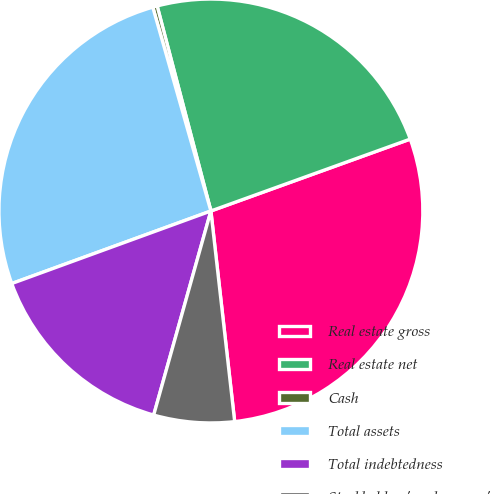Convert chart to OTSL. <chart><loc_0><loc_0><loc_500><loc_500><pie_chart><fcel>Real estate gross<fcel>Real estate net<fcel>Cash<fcel>Total assets<fcel>Total indebtedness<fcel>Stockholders' and owners'<nl><fcel>28.72%<fcel>23.57%<fcel>0.34%<fcel>26.14%<fcel>15.09%<fcel>6.14%<nl></chart> 